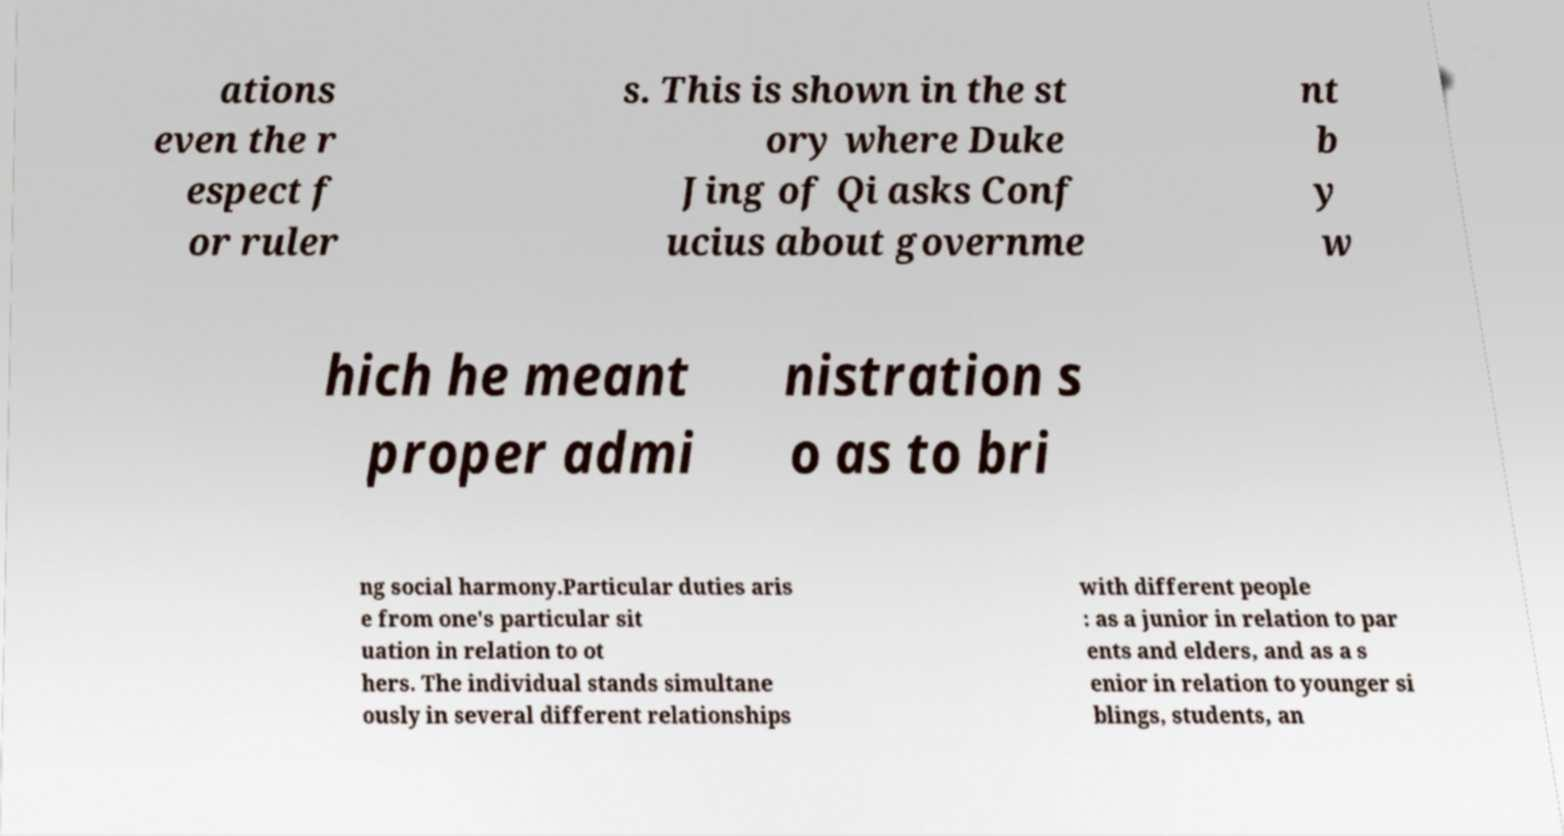What messages or text are displayed in this image? I need them in a readable, typed format. ations even the r espect f or ruler s. This is shown in the st ory where Duke Jing of Qi asks Conf ucius about governme nt b y w hich he meant proper admi nistration s o as to bri ng social harmony.Particular duties aris e from one's particular sit uation in relation to ot hers. The individual stands simultane ously in several different relationships with different people : as a junior in relation to par ents and elders, and as a s enior in relation to younger si blings, students, an 